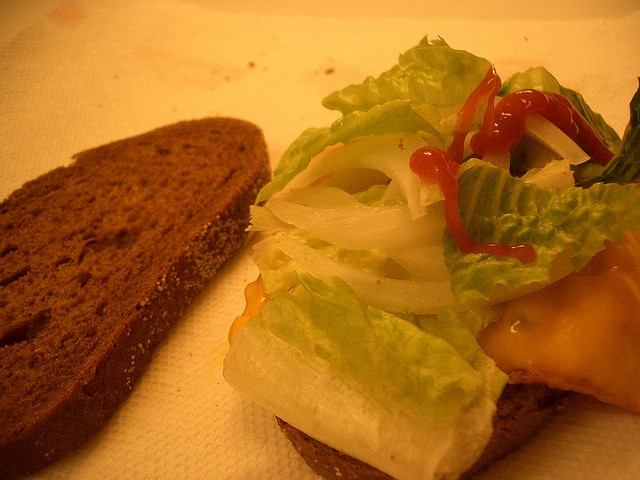Describe the objects in this image and their specific colors. I can see sandwich in brown, olive, orange, and maroon tones and sandwich in brown and maroon tones in this image. 